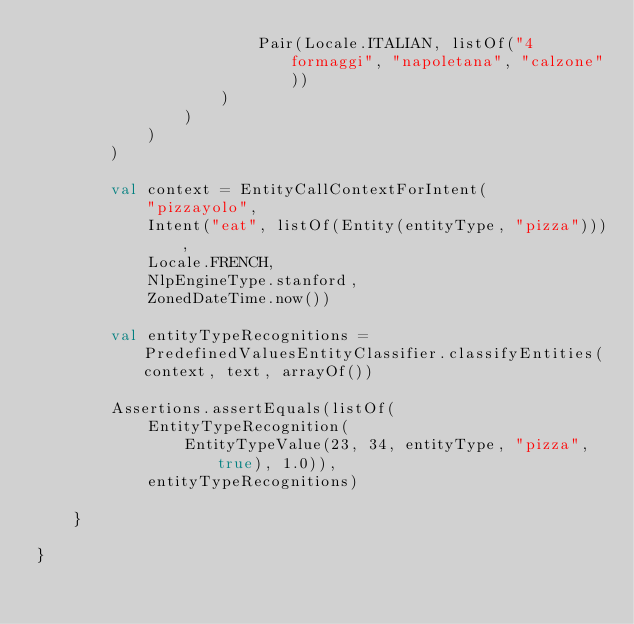<code> <loc_0><loc_0><loc_500><loc_500><_Kotlin_>                        Pair(Locale.ITALIAN, listOf("4 formaggi", "napoletana", "calzone"))
                    )
                )
            )
        )

        val context = EntityCallContextForIntent(
            "pizzayolo",
            Intent("eat", listOf(Entity(entityType, "pizza"))),
            Locale.FRENCH,
            NlpEngineType.stanford,
            ZonedDateTime.now())

        val entityTypeRecognitions = PredefinedValuesEntityClassifier.classifyEntities(context, text, arrayOf())

        Assertions.assertEquals(listOf(
            EntityTypeRecognition(
                EntityTypeValue(23, 34, entityType, "pizza", true), 1.0)),
            entityTypeRecognitions)

    }

}</code> 